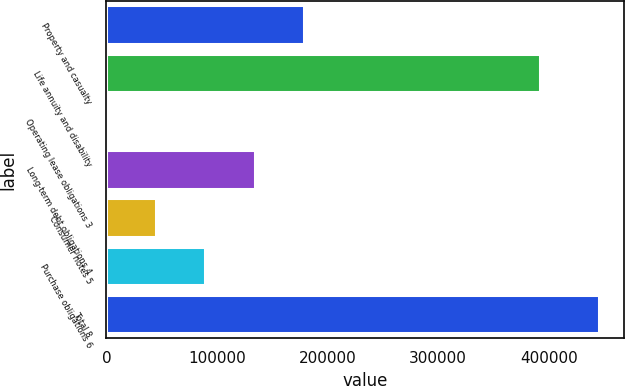Convert chart. <chart><loc_0><loc_0><loc_500><loc_500><bar_chart><fcel>Property and casualty<fcel>Life annuity and disability<fcel>Operating lease obligations 3<fcel>Long-term debt obligations 4<fcel>Consumer notes 5<fcel>Purchase obligations 6<fcel>Total 8<nl><fcel>178480<fcel>392118<fcel>498<fcel>133985<fcel>44993.6<fcel>89489.2<fcel>445454<nl></chart> 